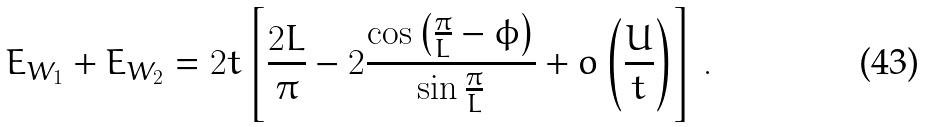<formula> <loc_0><loc_0><loc_500><loc_500>E _ { W _ { 1 } } + E _ { W _ { 2 } } = 2 t \left [ \frac { 2 L } { \pi } - 2 \frac { \cos \left ( \frac { \pi } { L } - \phi \right ) } { \sin \frac { \pi } { L } } + o \left ( \frac { U } { t } \right ) \right ] \, .</formula> 